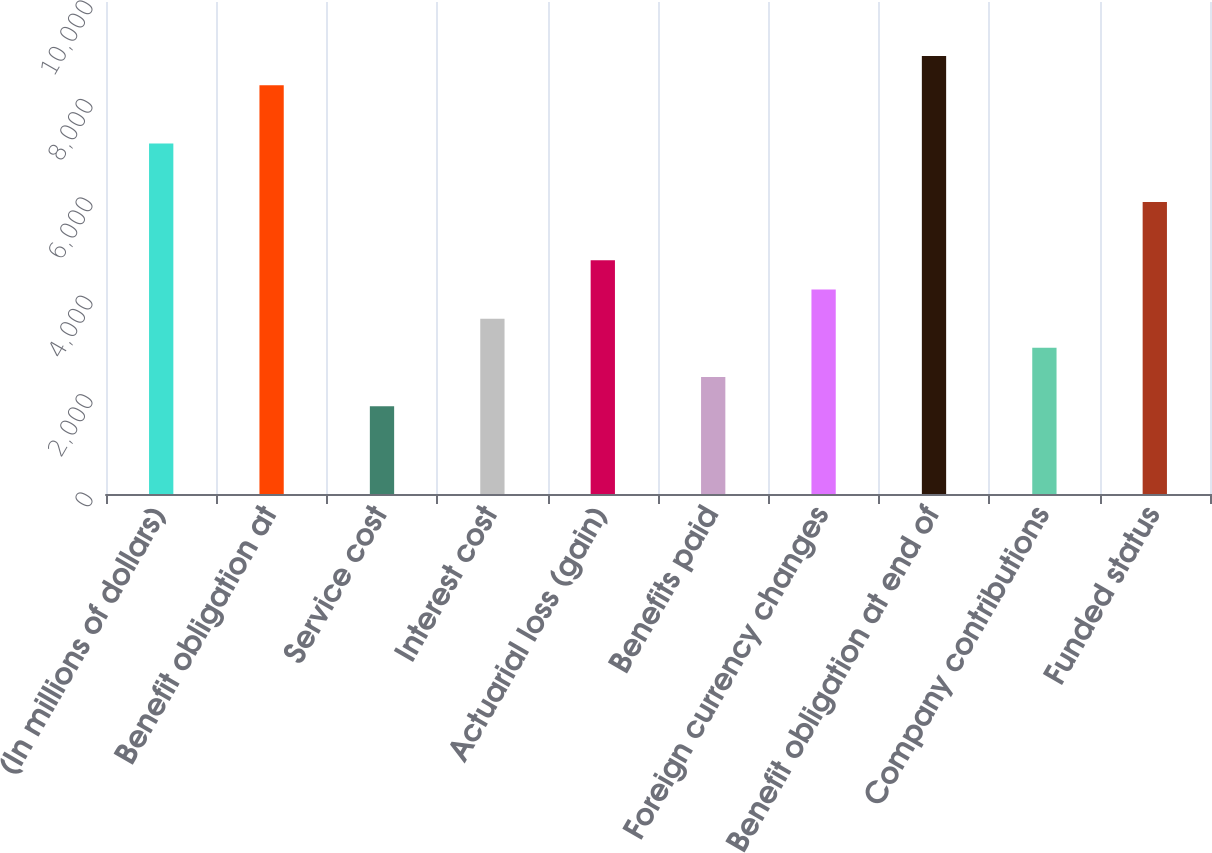<chart> <loc_0><loc_0><loc_500><loc_500><bar_chart><fcel>(In millions of dollars)<fcel>Benefit obligation at<fcel>Service cost<fcel>Interest cost<fcel>Actuarial loss (gain)<fcel>Benefits paid<fcel>Foreign currency changes<fcel>Benefit obligation at end of<fcel>Company contributions<fcel>Funded status<nl><fcel>7122.14<fcel>8308.28<fcel>1784.51<fcel>3563.72<fcel>4749.86<fcel>2377.58<fcel>4156.79<fcel>8901.35<fcel>2970.65<fcel>5936<nl></chart> 